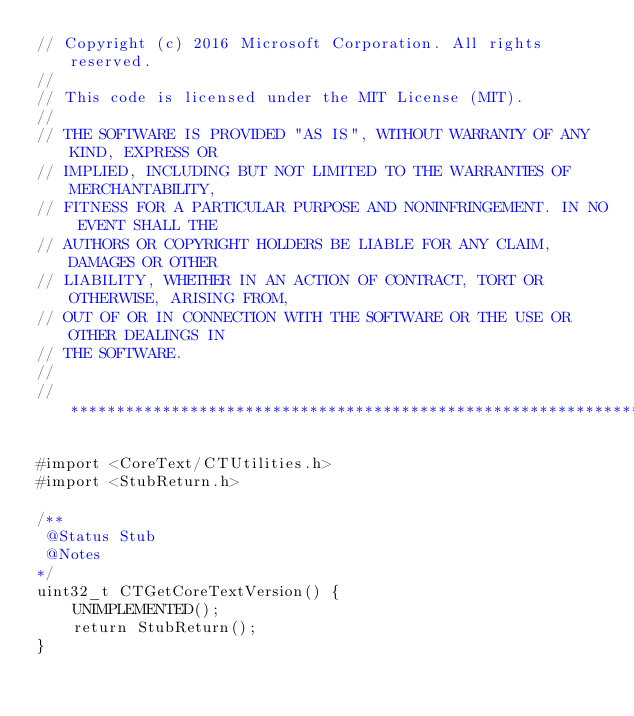<code> <loc_0><loc_0><loc_500><loc_500><_ObjectiveC_>// Copyright (c) 2016 Microsoft Corporation. All rights reserved.
//
// This code is licensed under the MIT License (MIT).
//
// THE SOFTWARE IS PROVIDED "AS IS", WITHOUT WARRANTY OF ANY KIND, EXPRESS OR
// IMPLIED, INCLUDING BUT NOT LIMITED TO THE WARRANTIES OF MERCHANTABILITY,
// FITNESS FOR A PARTICULAR PURPOSE AND NONINFRINGEMENT. IN NO EVENT SHALL THE
// AUTHORS OR COPYRIGHT HOLDERS BE LIABLE FOR ANY CLAIM, DAMAGES OR OTHER
// LIABILITY, WHETHER IN AN ACTION OF CONTRACT, TORT OR OTHERWISE, ARISING FROM,
// OUT OF OR IN CONNECTION WITH THE SOFTWARE OR THE USE OR OTHER DEALINGS IN
// THE SOFTWARE.
//
//******************************************************************************

#import <CoreText/CTUtilities.h>
#import <StubReturn.h>

/**
 @Status Stub
 @Notes
*/
uint32_t CTGetCoreTextVersion() {
    UNIMPLEMENTED();
    return StubReturn();
}
</code> 